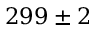Convert formula to latex. <formula><loc_0><loc_0><loc_500><loc_500>2 9 9 \pm 2</formula> 